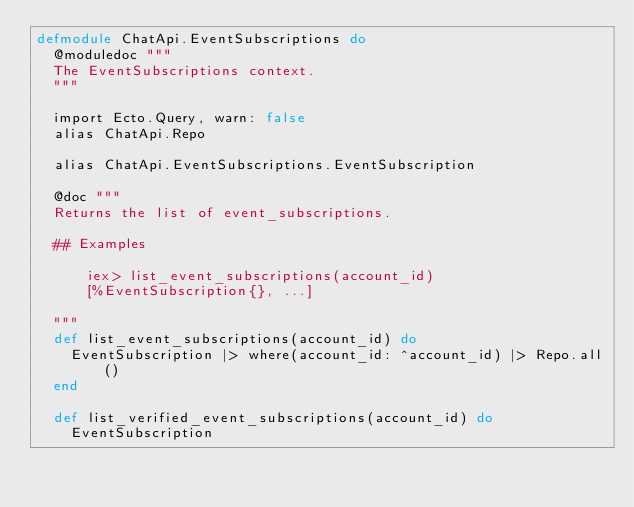Convert code to text. <code><loc_0><loc_0><loc_500><loc_500><_Elixir_>defmodule ChatApi.EventSubscriptions do
  @moduledoc """
  The EventSubscriptions context.
  """

  import Ecto.Query, warn: false
  alias ChatApi.Repo

  alias ChatApi.EventSubscriptions.EventSubscription

  @doc """
  Returns the list of event_subscriptions.

  ## Examples

      iex> list_event_subscriptions(account_id)
      [%EventSubscription{}, ...]

  """
  def list_event_subscriptions(account_id) do
    EventSubscription |> where(account_id: ^account_id) |> Repo.all()
  end

  def list_verified_event_subscriptions(account_id) do
    EventSubscription</code> 